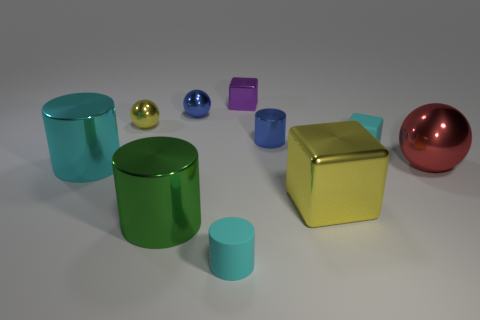What is the shape of the green thing that is made of the same material as the small yellow sphere?
Ensure brevity in your answer.  Cylinder. Is the number of small cyan rubber things behind the blue metal sphere less than the number of metal cubes to the right of the purple object?
Keep it short and to the point. Yes. Are there more large things than big cyan shiny things?
Your answer should be compact. Yes. What is the big yellow object made of?
Provide a succinct answer. Metal. There is a matte object right of the small metallic block; what is its color?
Your answer should be compact. Cyan. Is the number of blue metallic things in front of the tiny yellow ball greater than the number of blue shiny cylinders behind the blue cylinder?
Provide a short and direct response. Yes. There is a cyan rubber object behind the ball right of the cyan matte object that is right of the big yellow object; what is its size?
Offer a terse response. Small. Is there a shiny cylinder that has the same color as the tiny matte cube?
Provide a short and direct response. Yes. How many blue things are there?
Offer a terse response. 2. There is a yellow object that is on the right side of the big cylinder in front of the yellow object in front of the tiny yellow ball; what is its material?
Give a very brief answer. Metal. 